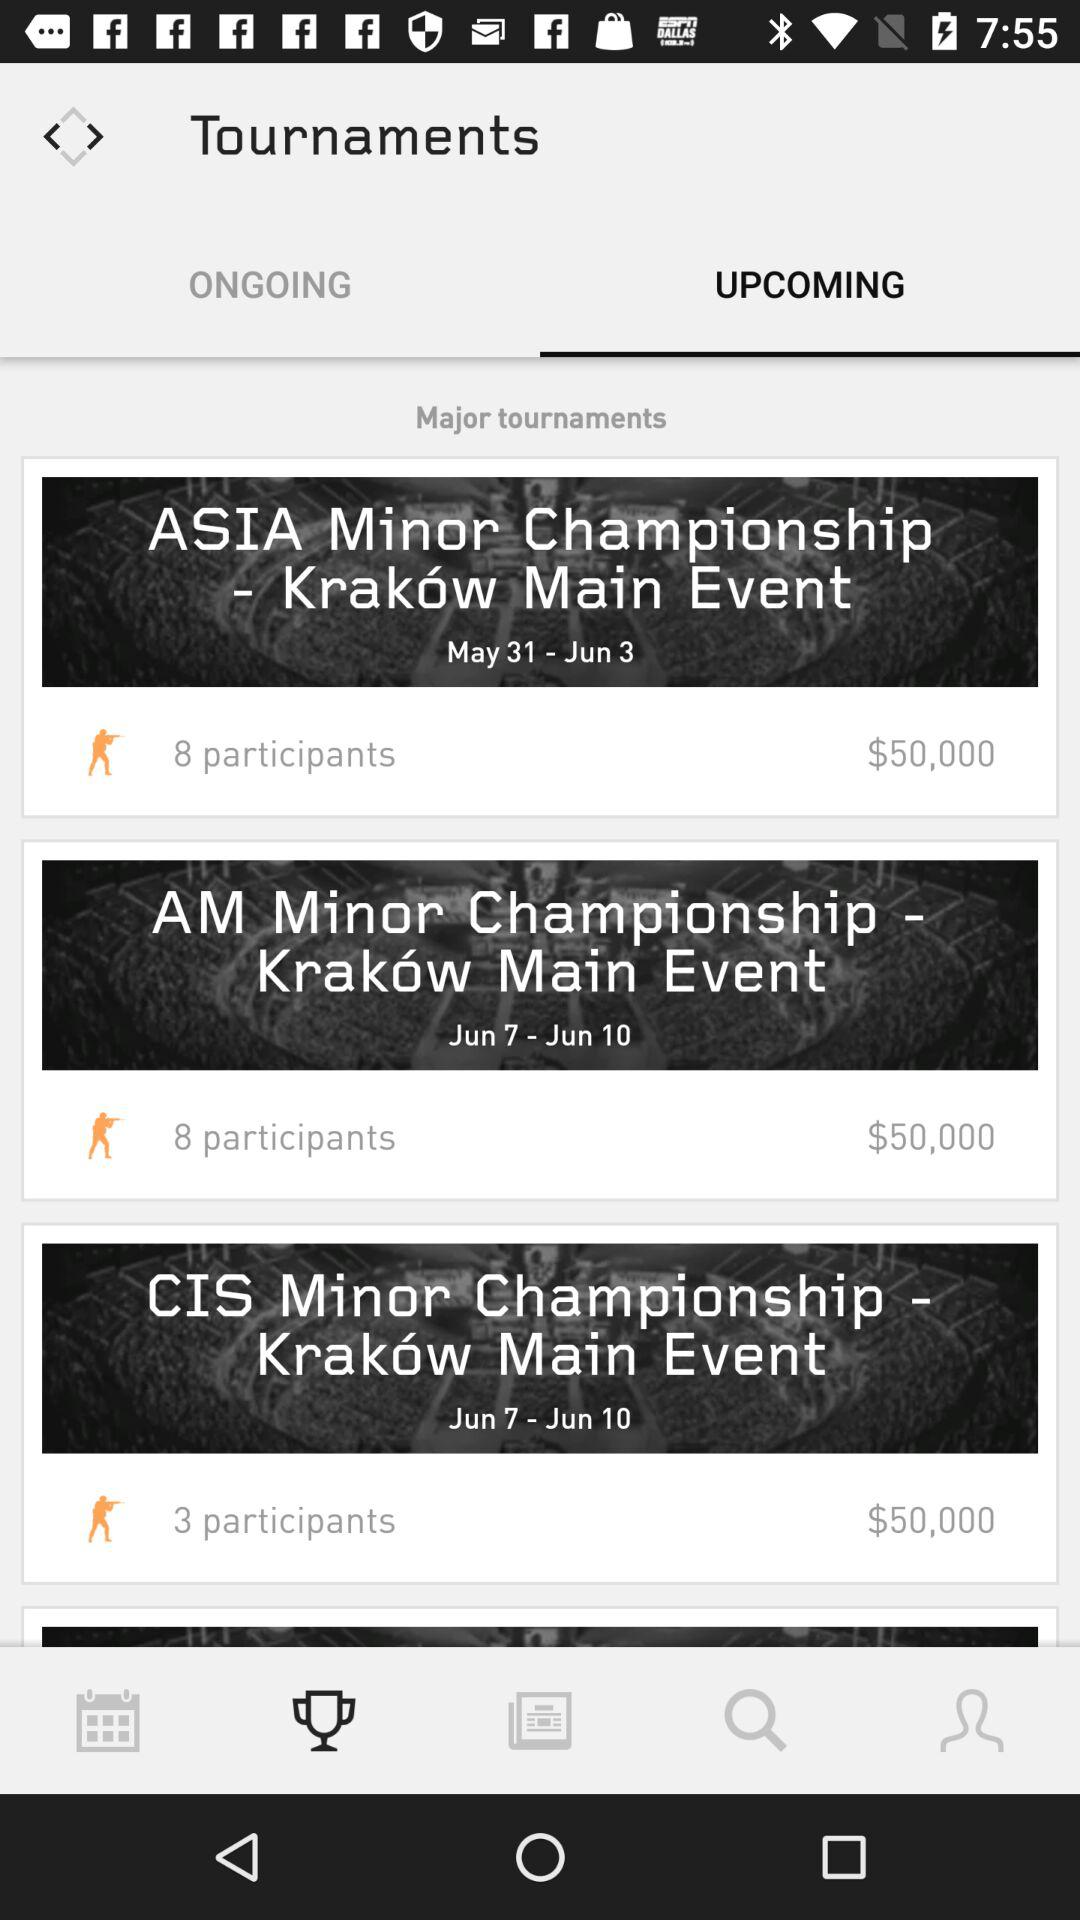What is the count of participants for the "CIS Minor Championship"? The count of participants is 3. 